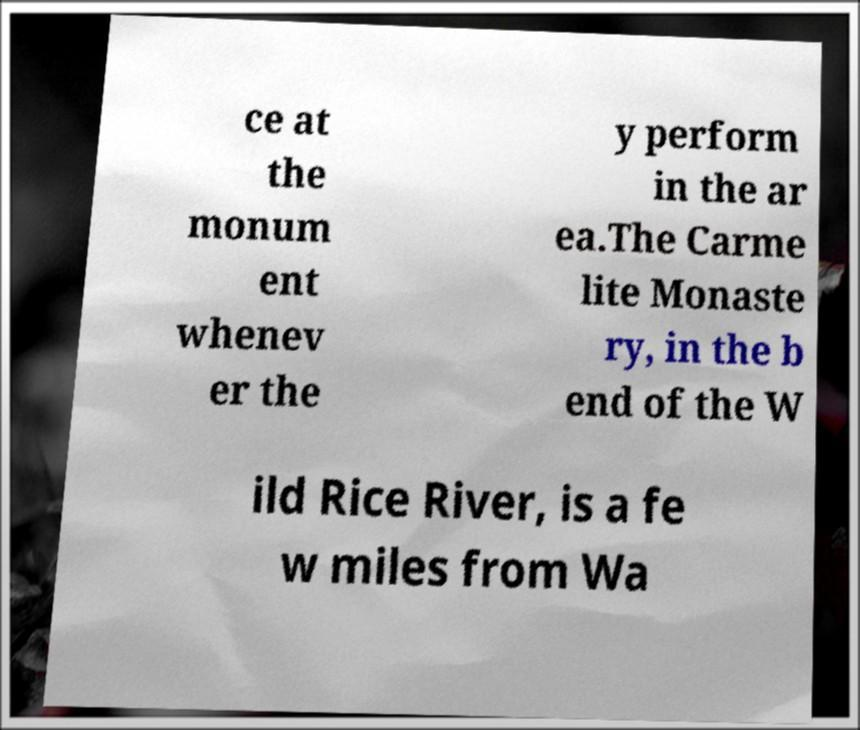Could you extract and type out the text from this image? ce at the monum ent whenev er the y perform in the ar ea.The Carme lite Monaste ry, in the b end of the W ild Rice River, is a fe w miles from Wa 